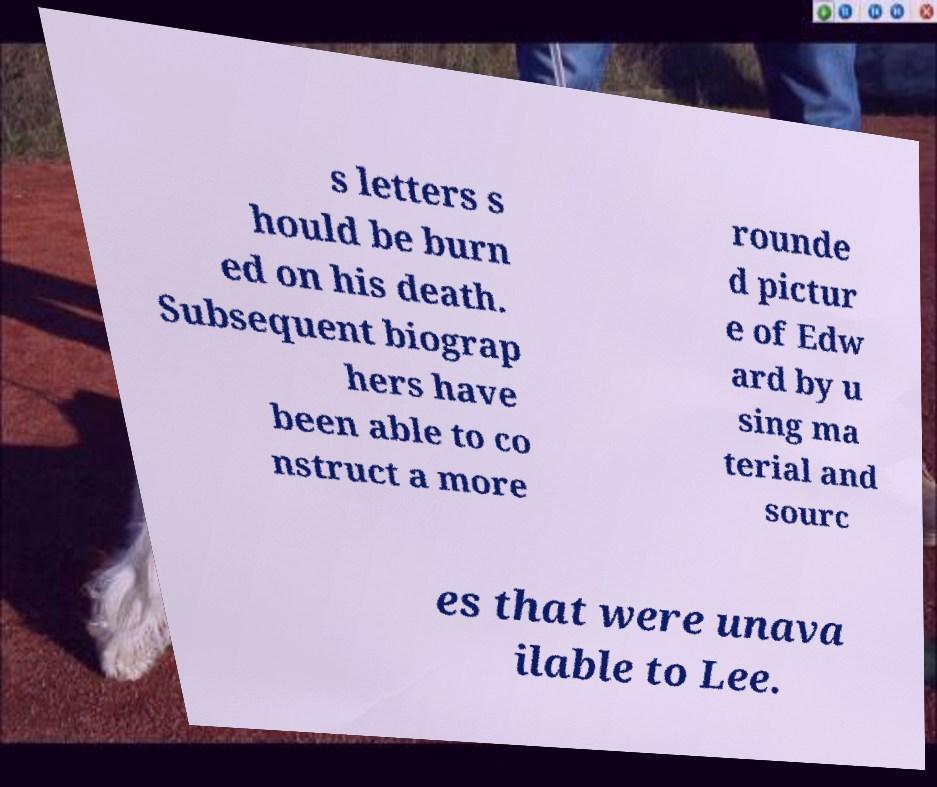Please identify and transcribe the text found in this image. s letters s hould be burn ed on his death. Subsequent biograp hers have been able to co nstruct a more rounde d pictur e of Edw ard by u sing ma terial and sourc es that were unava ilable to Lee. 